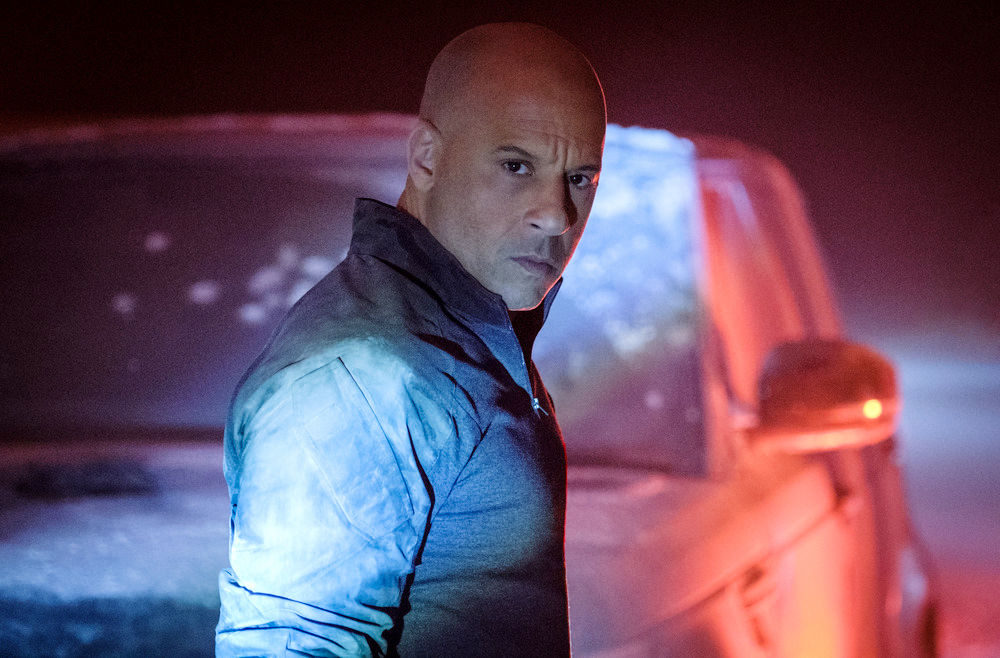Can you describe how the lighting affects the perception of this scene? The lighting in the image, primarily coming from behind the subject and the glowing rear lights of the car, creates a subdued and shadowy environment. This lighting choice not only focuses the viewer's attention on the man by highlighting his figure with the shiny texture of his jacket but also contributes to the overall mood by casting deep shadows, enhancing elements of mystery and uncertainty. 